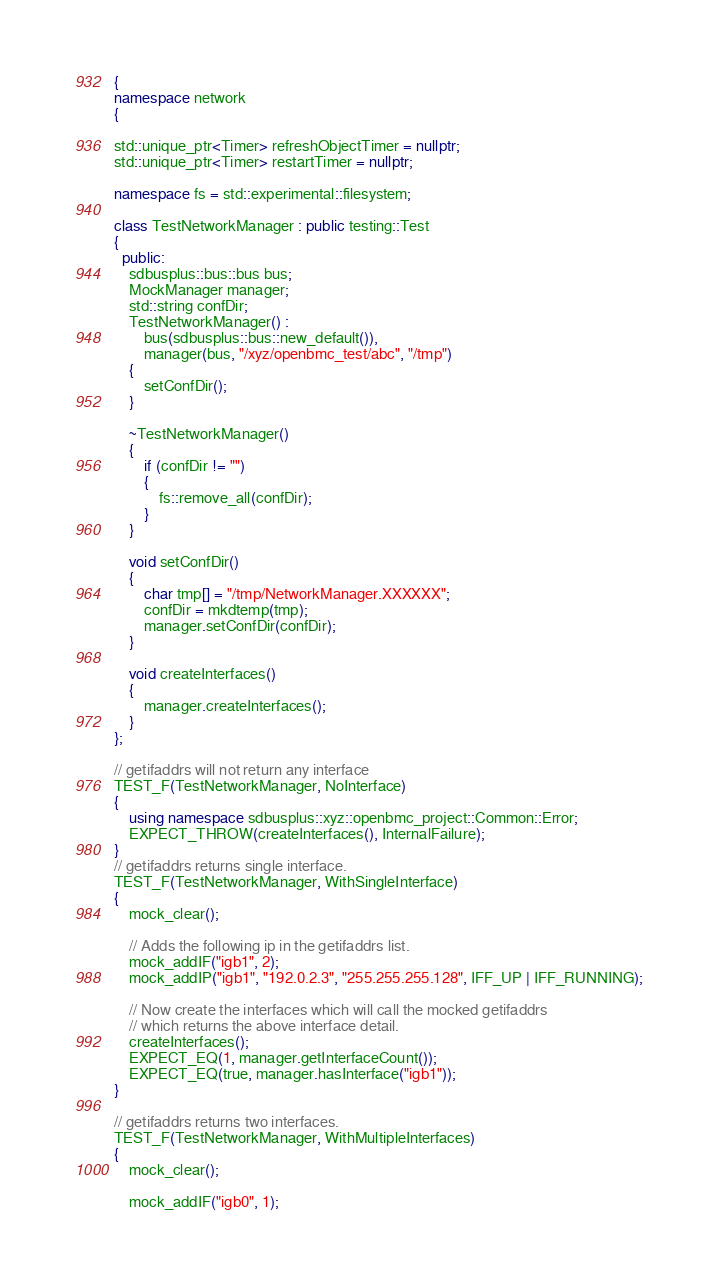Convert code to text. <code><loc_0><loc_0><loc_500><loc_500><_C++_>{
namespace network
{

std::unique_ptr<Timer> refreshObjectTimer = nullptr;
std::unique_ptr<Timer> restartTimer = nullptr;

namespace fs = std::experimental::filesystem;

class TestNetworkManager : public testing::Test
{
  public:
    sdbusplus::bus::bus bus;
    MockManager manager;
    std::string confDir;
    TestNetworkManager() :
        bus(sdbusplus::bus::new_default()),
        manager(bus, "/xyz/openbmc_test/abc", "/tmp")
    {
        setConfDir();
    }

    ~TestNetworkManager()
    {
        if (confDir != "")
        {
            fs::remove_all(confDir);
        }
    }

    void setConfDir()
    {
        char tmp[] = "/tmp/NetworkManager.XXXXXX";
        confDir = mkdtemp(tmp);
        manager.setConfDir(confDir);
    }

    void createInterfaces()
    {
        manager.createInterfaces();
    }
};

// getifaddrs will not return any interface
TEST_F(TestNetworkManager, NoInterface)
{
    using namespace sdbusplus::xyz::openbmc_project::Common::Error;
    EXPECT_THROW(createInterfaces(), InternalFailure);
}
// getifaddrs returns single interface.
TEST_F(TestNetworkManager, WithSingleInterface)
{
    mock_clear();

    // Adds the following ip in the getifaddrs list.
    mock_addIF("igb1", 2);
    mock_addIP("igb1", "192.0.2.3", "255.255.255.128", IFF_UP | IFF_RUNNING);

    // Now create the interfaces which will call the mocked getifaddrs
    // which returns the above interface detail.
    createInterfaces();
    EXPECT_EQ(1, manager.getInterfaceCount());
    EXPECT_EQ(true, manager.hasInterface("igb1"));
}

// getifaddrs returns two interfaces.
TEST_F(TestNetworkManager, WithMultipleInterfaces)
{
    mock_clear();

    mock_addIF("igb0", 1);</code> 